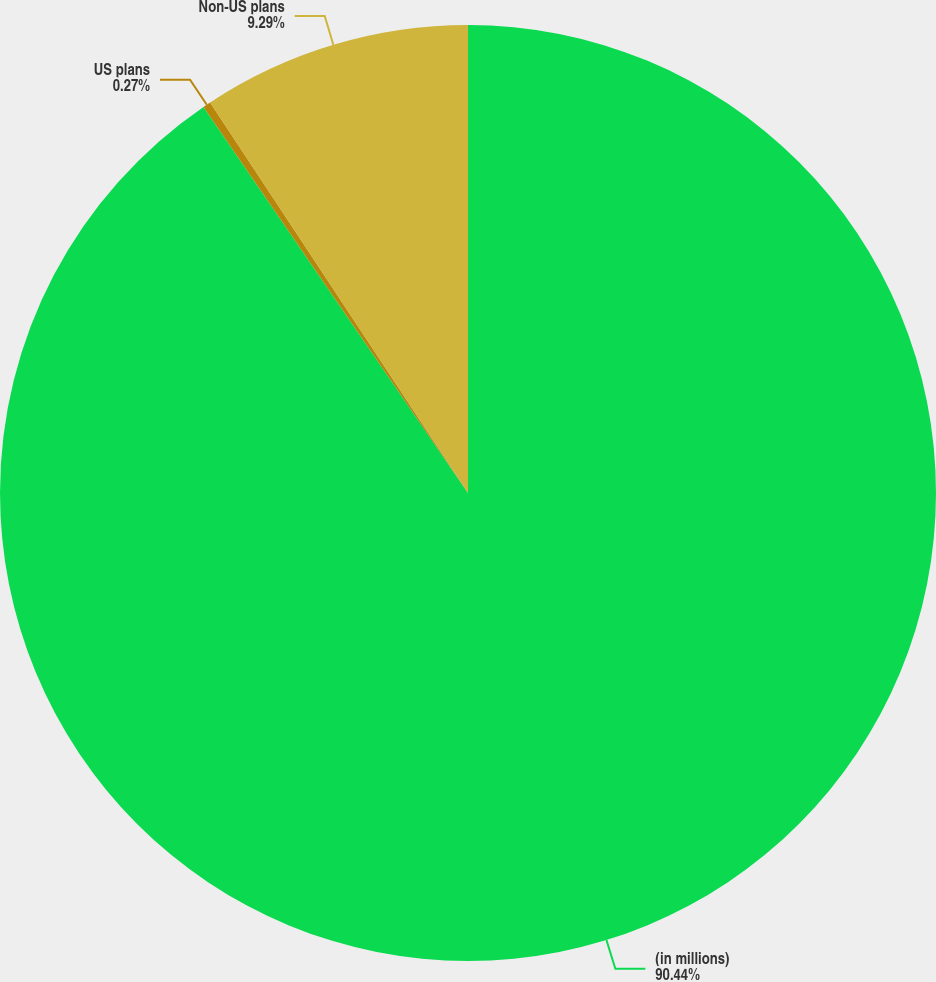Convert chart to OTSL. <chart><loc_0><loc_0><loc_500><loc_500><pie_chart><fcel>(in millions)<fcel>US plans<fcel>Non-US plans<nl><fcel>90.44%<fcel>0.27%<fcel>9.29%<nl></chart> 